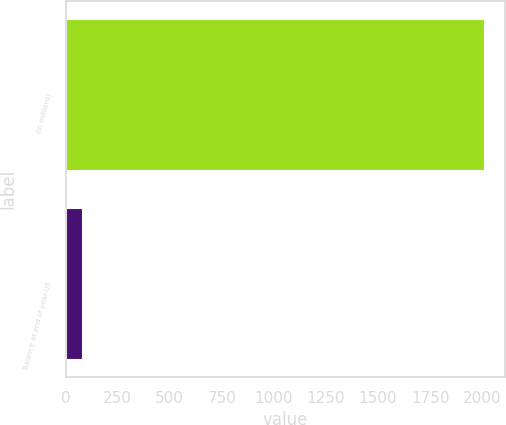Convert chart to OTSL. <chart><loc_0><loc_0><loc_500><loc_500><bar_chart><fcel>(In millions)<fcel>Balance at end of year-US<nl><fcel>2009<fcel>79<nl></chart> 